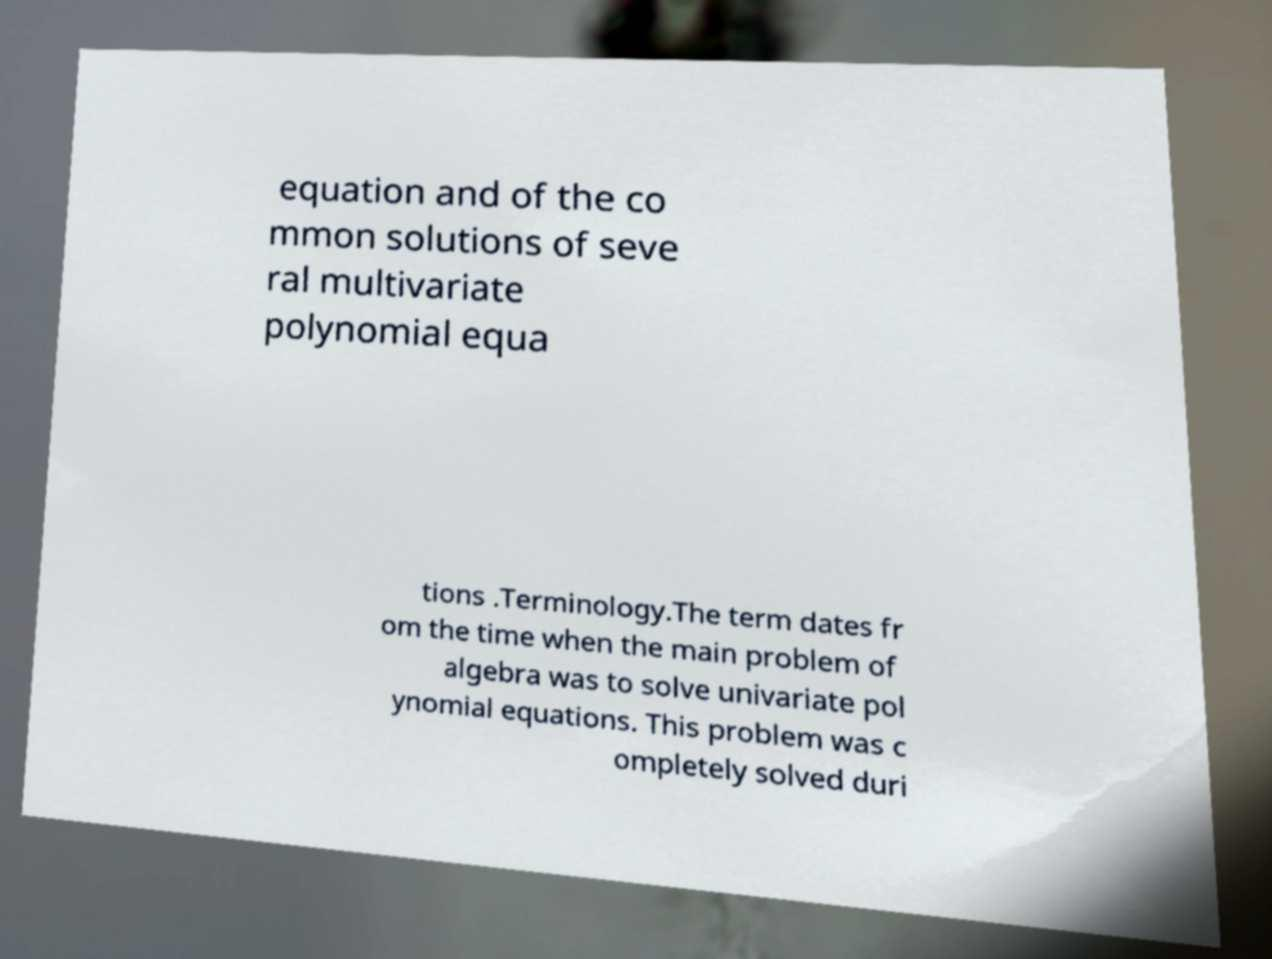Please identify and transcribe the text found in this image. equation and of the co mmon solutions of seve ral multivariate polynomial equa tions .Terminology.The term dates fr om the time when the main problem of algebra was to solve univariate pol ynomial equations. This problem was c ompletely solved duri 